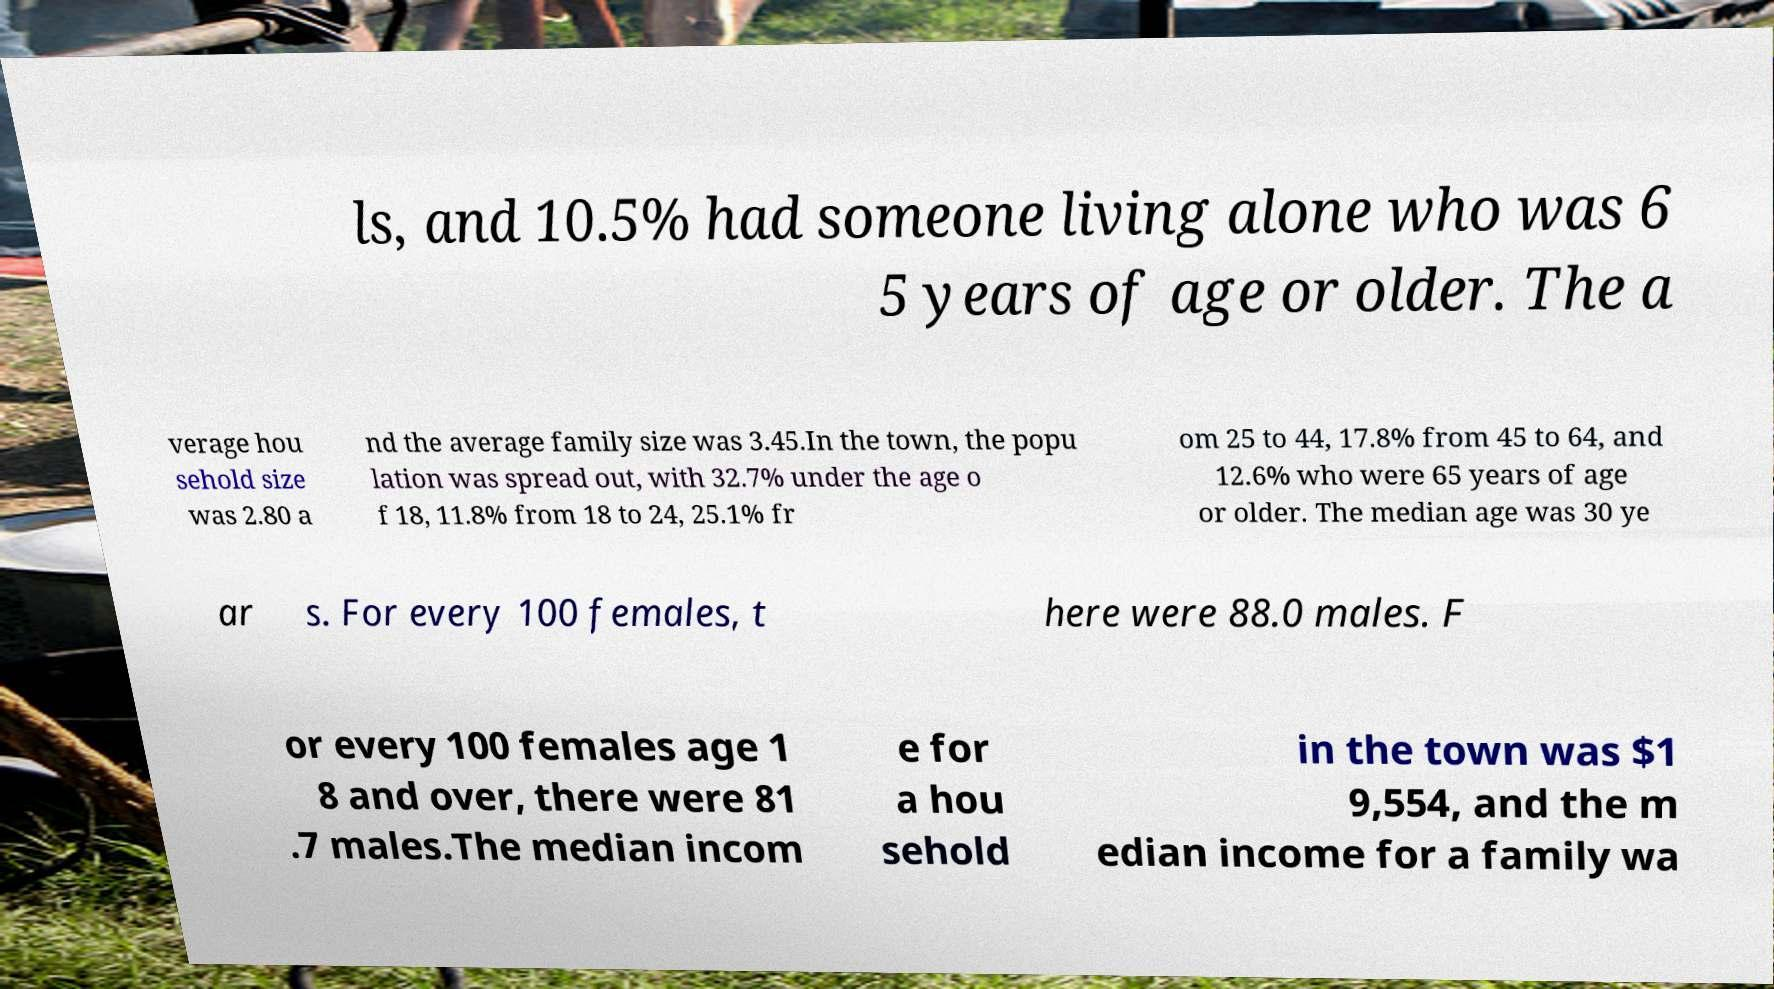I need the written content from this picture converted into text. Can you do that? ls, and 10.5% had someone living alone who was 6 5 years of age or older. The a verage hou sehold size was 2.80 a nd the average family size was 3.45.In the town, the popu lation was spread out, with 32.7% under the age o f 18, 11.8% from 18 to 24, 25.1% fr om 25 to 44, 17.8% from 45 to 64, and 12.6% who were 65 years of age or older. The median age was 30 ye ar s. For every 100 females, t here were 88.0 males. F or every 100 females age 1 8 and over, there were 81 .7 males.The median incom e for a hou sehold in the town was $1 9,554, and the m edian income for a family wa 